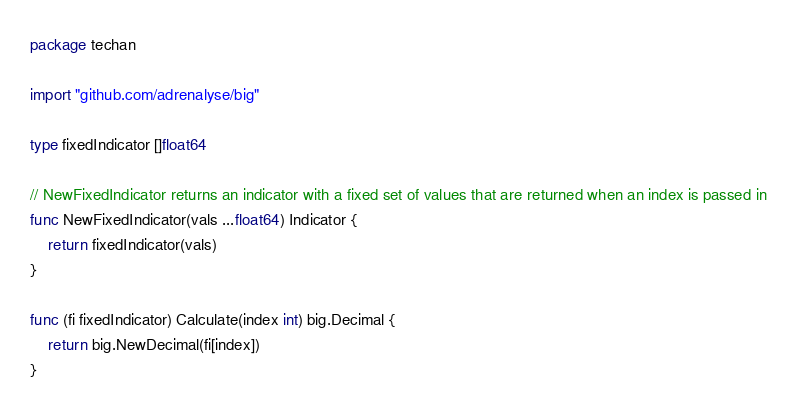Convert code to text. <code><loc_0><loc_0><loc_500><loc_500><_Go_>package techan

import "github.com/adrenalyse/big"

type fixedIndicator []float64

// NewFixedIndicator returns an indicator with a fixed set of values that are returned when an index is passed in
func NewFixedIndicator(vals ...float64) Indicator {
	return fixedIndicator(vals)
}

func (fi fixedIndicator) Calculate(index int) big.Decimal {
	return big.NewDecimal(fi[index])
}
</code> 